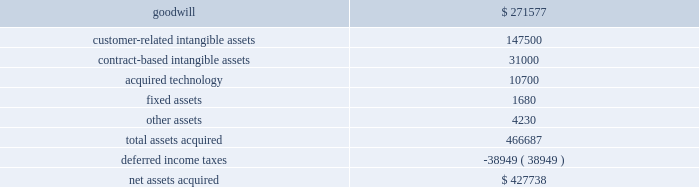Cash and a commitment to fund the capital needs of the business until such time as its cumulative funding is equal to funding that we have provided from inception through the effective date of the transaction .
The transaction created a new joint venture which does business as comercia global payments brazil .
As a result of the transaction , we deconsolidated global payments brazil , and we apply the equity method of accounting to our retained interest in comercia global payments brazil .
We recorded a gain on the transaction of $ 2.1 million which is included in interest and other income in the consolidated statement of income for the fiscal year ended may 31 , 2014 .
The results of the brazil operation from inception until the restructuring into a joint venture on september 30 , 2013 were not material to our consolidated results of operations , and the assets and liabilities that we derecognized were not material to our consolidated balance sheet .
American express portfolio on october 24 , 2013 , we acquired a merchant portfolio in the czech republic from american express limited for $ 1.9 million .
The acquired assets have been classified as customer-related intangible assets and contract-based intangible assets with estimated amortization periods of 10 years .
Paypros on march 4 , 2014 , we completed the acquisition of 100% ( 100 % ) of the outstanding stock of payment processing , inc .
( 201cpaypros 201d ) for $ 420.0 million in cash plus $ 7.7 million in cash for working capital , subject to adjustment based on a final determination of working capital .
We funded the acquisition with a combination of cash on hand and proceeds from our new term loan .
Paypros , based in california , is a provider of fully-integrated payment solutions for small-to-medium sized merchants in the united states .
Paypros delivers its products and services through a network of technology-based enterprise software partners to vertical markets that are complementary to the markets served by accelerated payment technologies ( 201capt 201d ) , which we acquired in october 2012 .
We acquired paypros to expand our direct distribution capabilities in the united states and to further enhance our existing integrated solutions offerings .
This acquisition was recorded as a business combination , and the purchase price was allocated to the assets acquired and liabilities assumed based on their estimated fair values .
Due to the timing of this transaction , the allocation of the purchase price is preliminary pending final valuation of intangible assets and deferred income taxes as well as resolution of the working capital settlement discussed above .
The purchase price of paypros was determined by analyzing the historical and prospective financial statements .
Acquisition costs associated with this purchase were not material .
The table summarizes the preliminary purchase price allocation ( in thousands ) : .
The preliminary purchase price allocation resulted in goodwill , included in the north america merchant services segment , of $ 271.6 million .
Such goodwill is attributable primarily to synergies with the services offered and markets served by paypros .
The goodwill associated with the acquisition is not deductible for tax purposes .
The customer-related intangible assets and the contract-based intangible assets have an estimated amortization period of 13 years .
The acquired technology has an estimated amortization period of 7 years. .
What percent of assets for the acquisition of paypros was deductible for taxes? 
Rationale: to find the percentage of assets that are tax deductible one will nee to added all the intangible assets and technology acquisitions . then they will divide that answer by the total amount of assets .
Computations: ((147500 + (10700 + 31000)) / 466687)
Answer: 0.40541. 